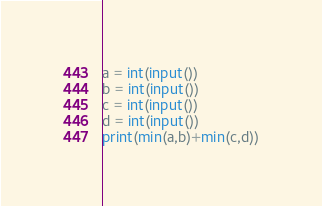<code> <loc_0><loc_0><loc_500><loc_500><_Python_>a = int(input())
b = int(input())
c = int(input())
d = int(input())
print(min(a,b)+min(c,d))</code> 